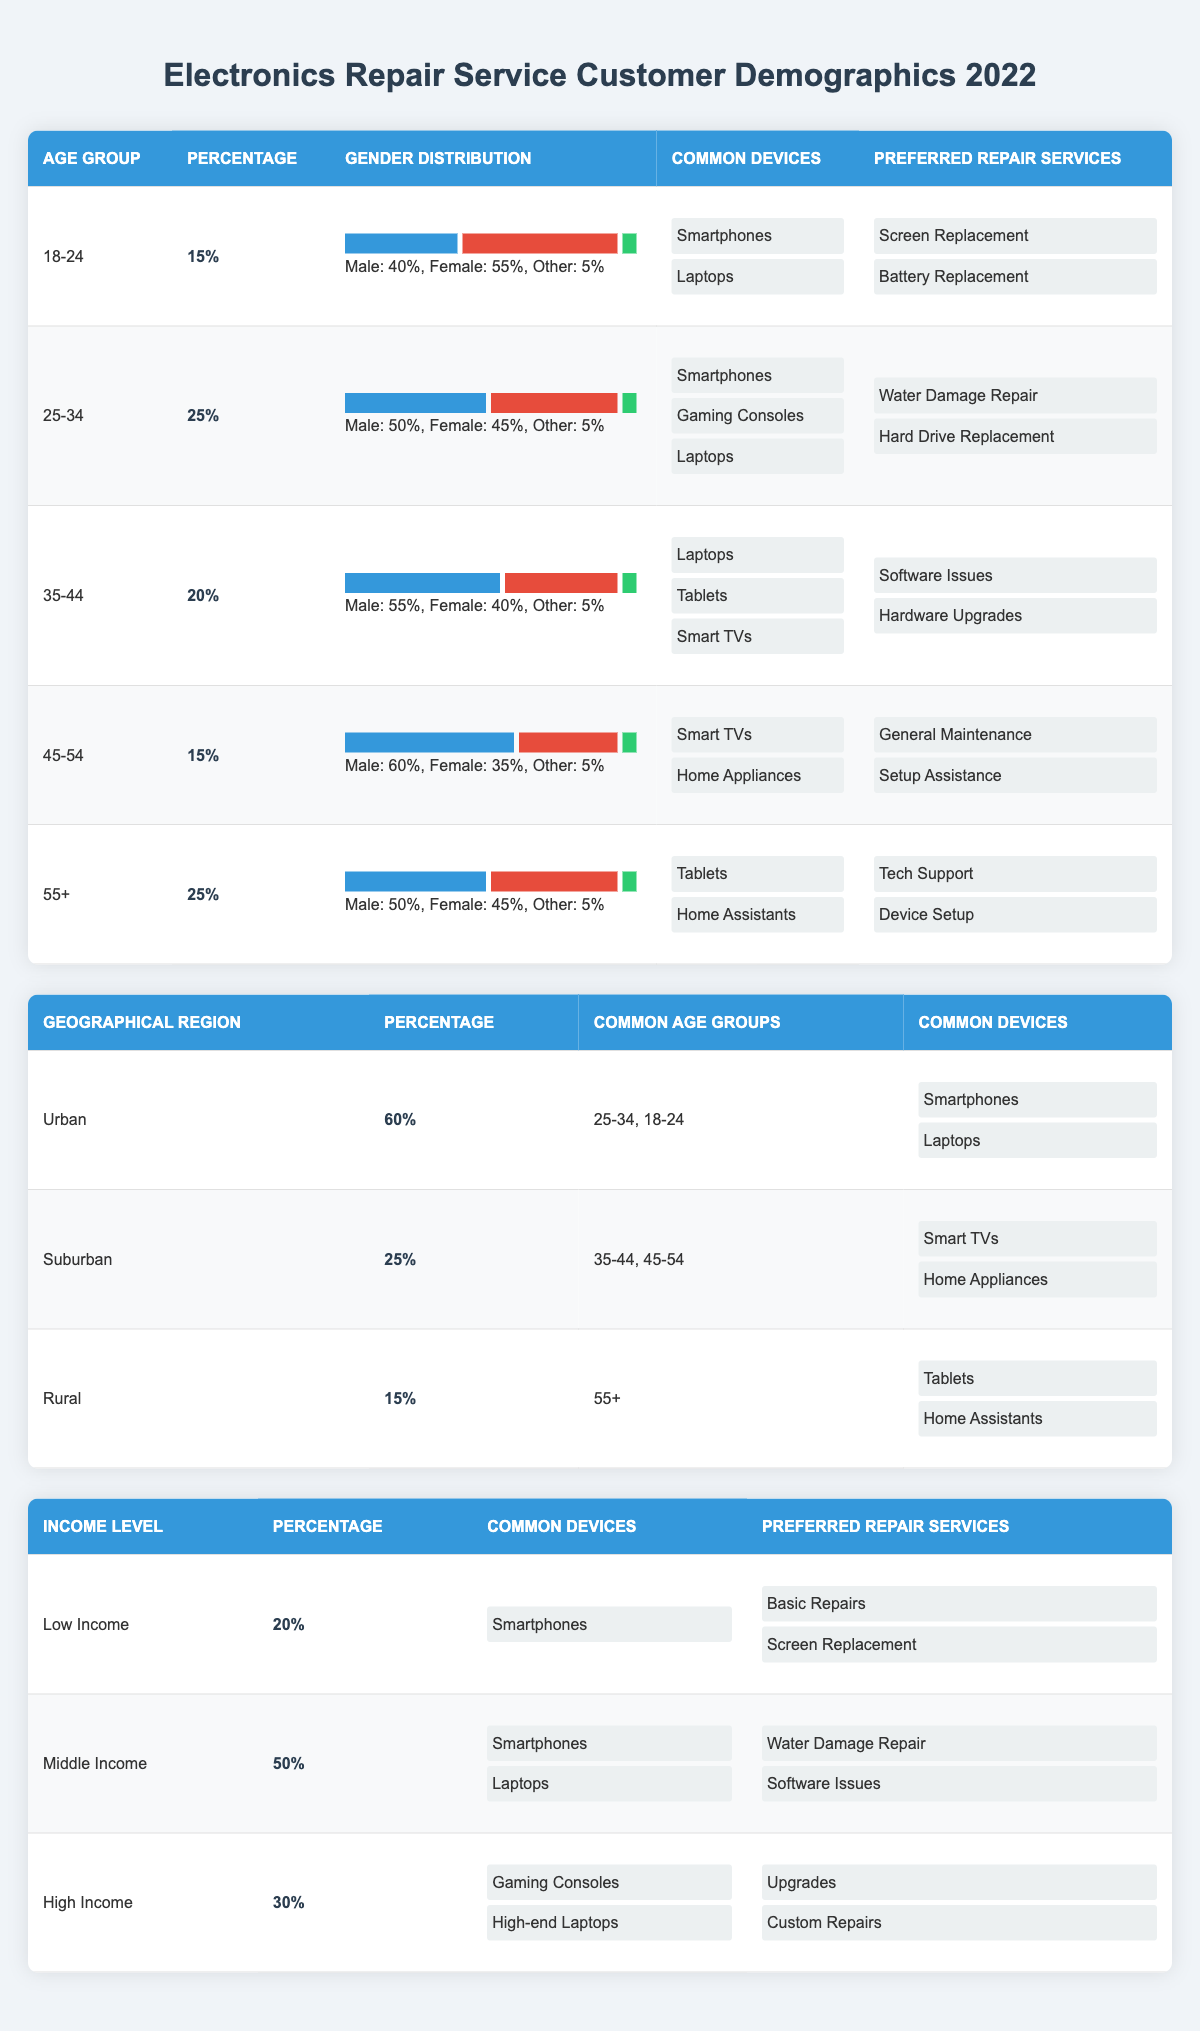What percentage of customers are in the age group 25-34? The age group 25-34 has a percentage value listed in the table, which is directly specified as 25%.
Answer: 25% Which age group has the highest percentage of male customers? By examining the gender distribution across all age groups, the 45-54 age group shows a male percentage of 60%, which is the highest among all groups.
Answer: 45-54 What are the common devices used by customers aged 55 and above? Looking at the row for the age group 55+, the common devices listed are Tablets and Home Assistants.
Answer: Tablets, Home Assistants Which geographical region has the highest customer percentage? The Urban region is listed with a customer percentage of 60%, which is higher than both Suburban (25%) and Rural (15%) regions.
Answer: Urban Are there more male or female customers in the age group 18-24? Within the age group 18-24, female customers represent 55% compared to 40% male customers, indicating there are more female customers.
Answer: Yes What percentage of middle-income customers prefer water damage repair? From the income levels table, middle-income customers account for 50% of the total and they prefer Water Damage Repair as one of their main services, alongside software issues.
Answer: 50% In which age group are home appliances the most common device? By inspecting the age groups, Home Appliances are listed as common devices for the 45-54 age group.
Answer: 45-54 What is the total percentage of customers in suburban and rural areas combined? Adding the percentages for Suburban (25%) and Rural (15%) gives a total of 40%. Therefore, the combined percentage is 25% + 15% = 40%.
Answer: 40% Which income level has the lowest percentage of customers, and what is that percentage? The Low Income category has the lowest percentage, which is listed as 20% in the income levels table.
Answer: Low Income: 20% 